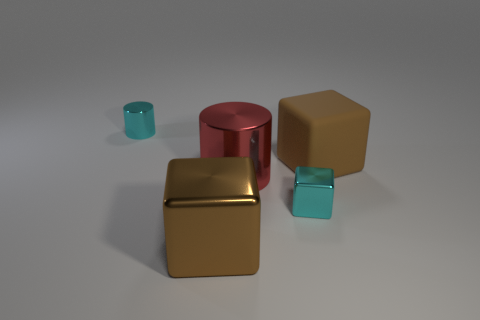Add 1 shiny cylinders. How many objects exist? 6 Subtract all cylinders. How many objects are left? 3 Subtract 0 purple balls. How many objects are left? 5 Subtract all small cyan blocks. Subtract all cyan shiny cylinders. How many objects are left? 3 Add 5 large brown metal blocks. How many large brown metal blocks are left? 6 Add 1 yellow metallic balls. How many yellow metallic balls exist? 1 